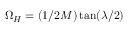<formula> <loc_0><loc_0><loc_500><loc_500>\Omega _ { H } = ( 1 / 2 M ) \tan ( \lambda / 2 )</formula> 